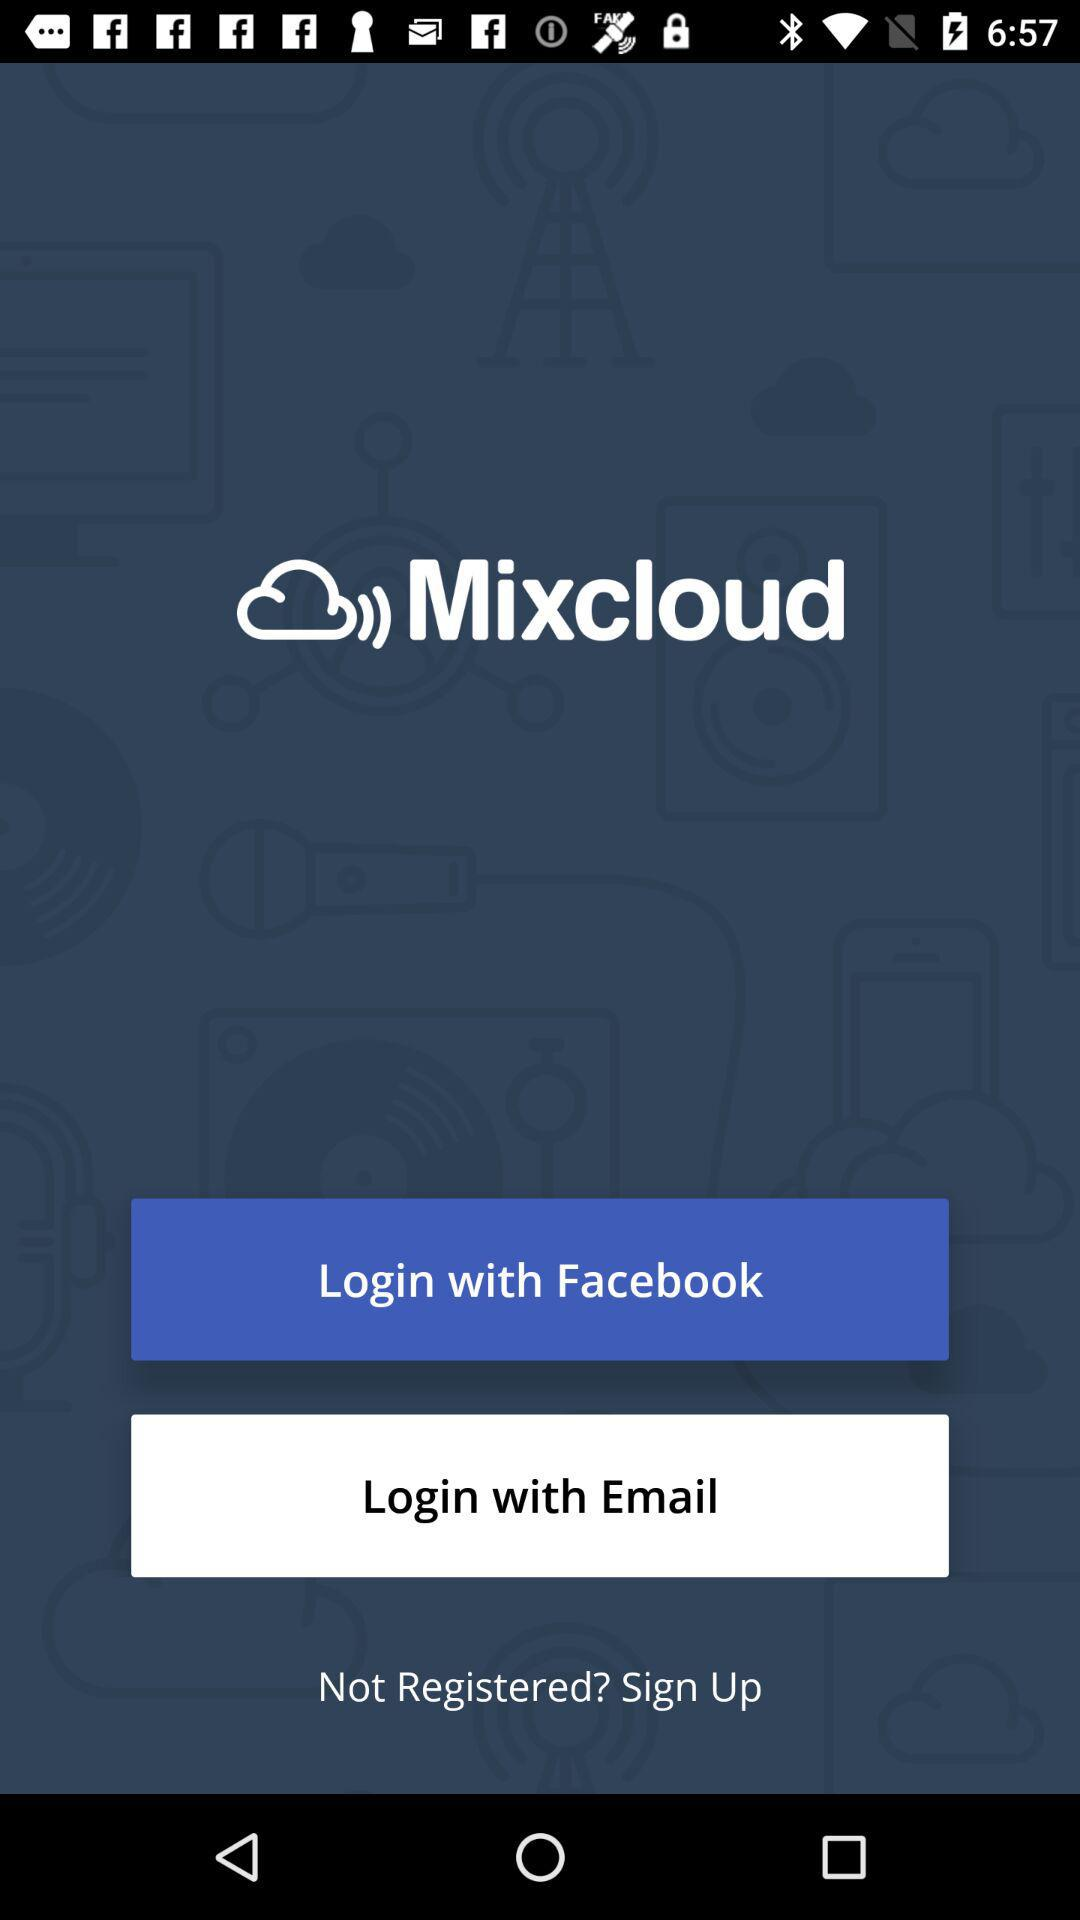What is the application name? The application name is "Mixcloud". 